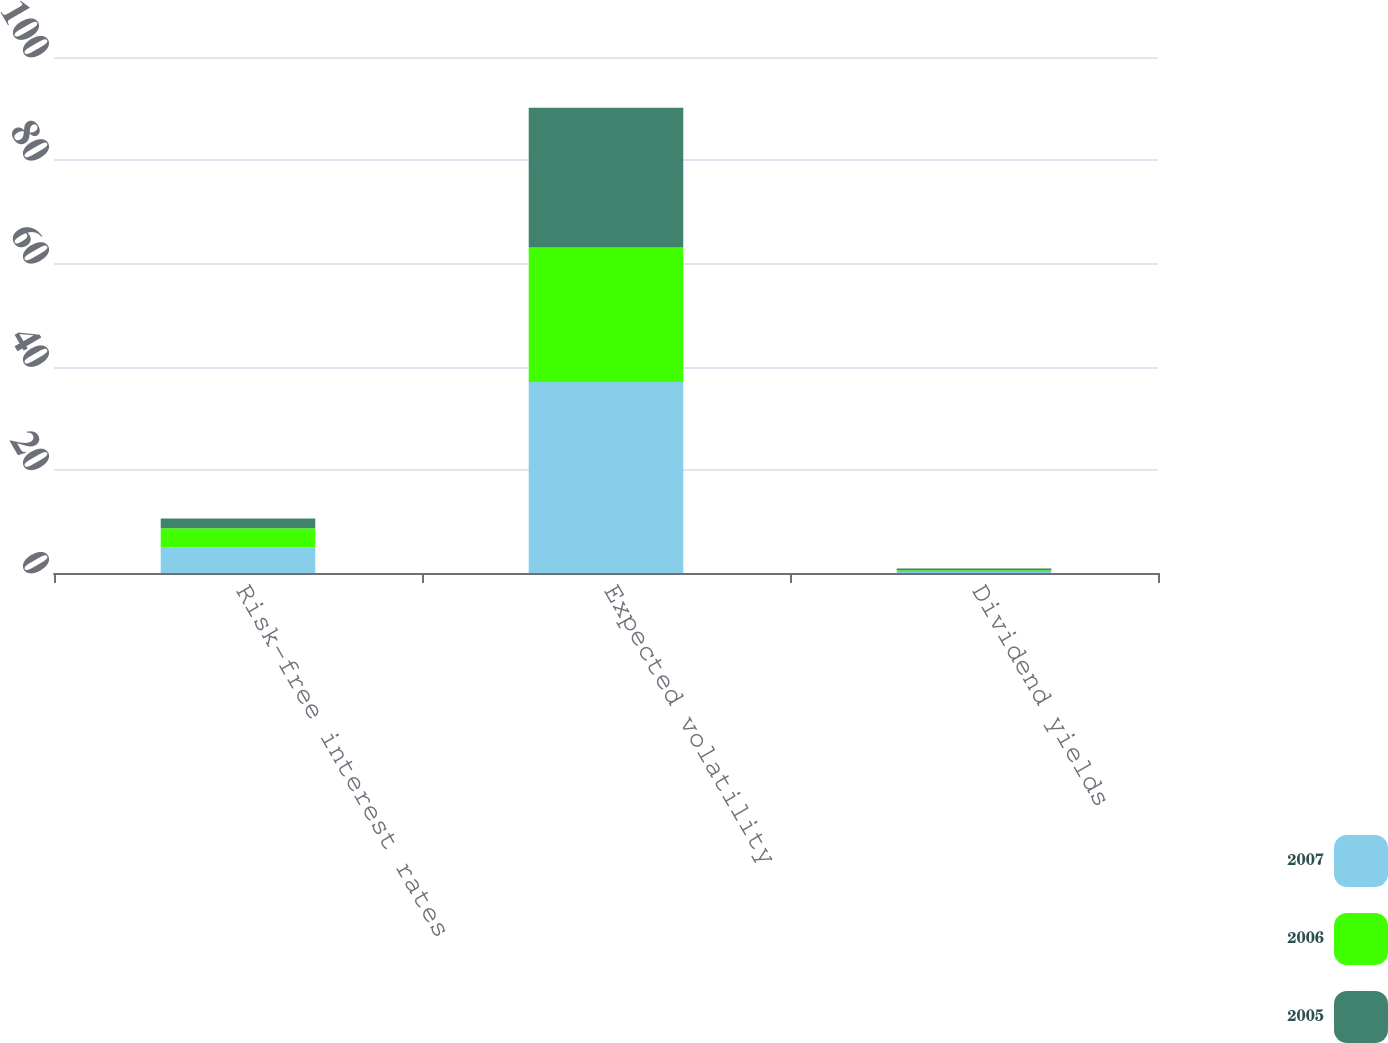<chart> <loc_0><loc_0><loc_500><loc_500><stacked_bar_chart><ecel><fcel>Risk-free interest rates<fcel>Expected volatility<fcel>Dividend yields<nl><fcel>2007<fcel>4.93<fcel>37.02<fcel>0.19<nl><fcel>2006<fcel>3.72<fcel>26.06<fcel>0.34<nl><fcel>2005<fcel>1.93<fcel>27.09<fcel>0.34<nl></chart> 